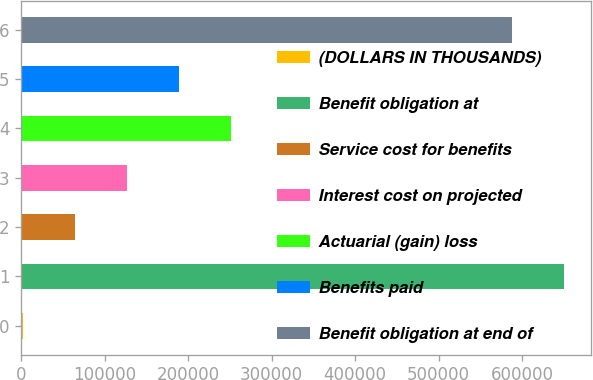Convert chart. <chart><loc_0><loc_0><loc_500><loc_500><bar_chart><fcel>(DOLLARS IN THOUSANDS)<fcel>Benefit obligation at<fcel>Service cost for benefits<fcel>Interest cost on projected<fcel>Actuarial (gain) loss<fcel>Benefits paid<fcel>Benefit obligation at end of<nl><fcel>2015<fcel>649857<fcel>64361.4<fcel>126708<fcel>251401<fcel>189054<fcel>587511<nl></chart> 